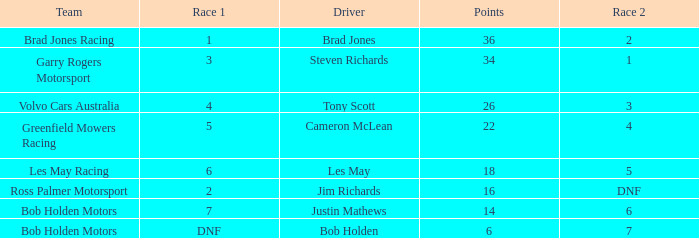Which driver for Greenfield Mowers Racing has fewer than 36 points? Cameron McLean. 